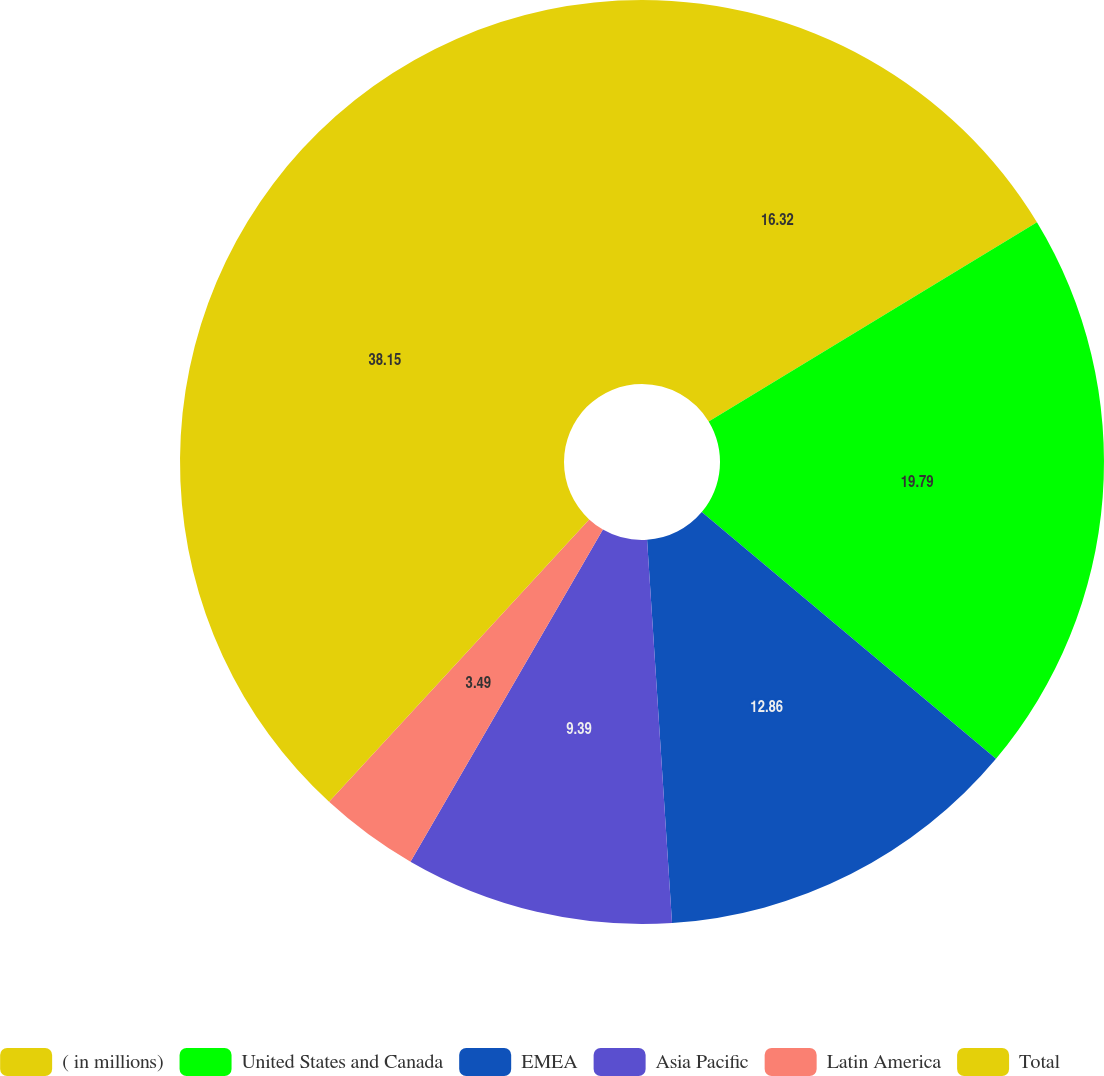Convert chart. <chart><loc_0><loc_0><loc_500><loc_500><pie_chart><fcel>( in millions)<fcel>United States and Canada<fcel>EMEA<fcel>Asia Pacific<fcel>Latin America<fcel>Total<nl><fcel>16.32%<fcel>19.79%<fcel>12.86%<fcel>9.39%<fcel>3.49%<fcel>38.16%<nl></chart> 